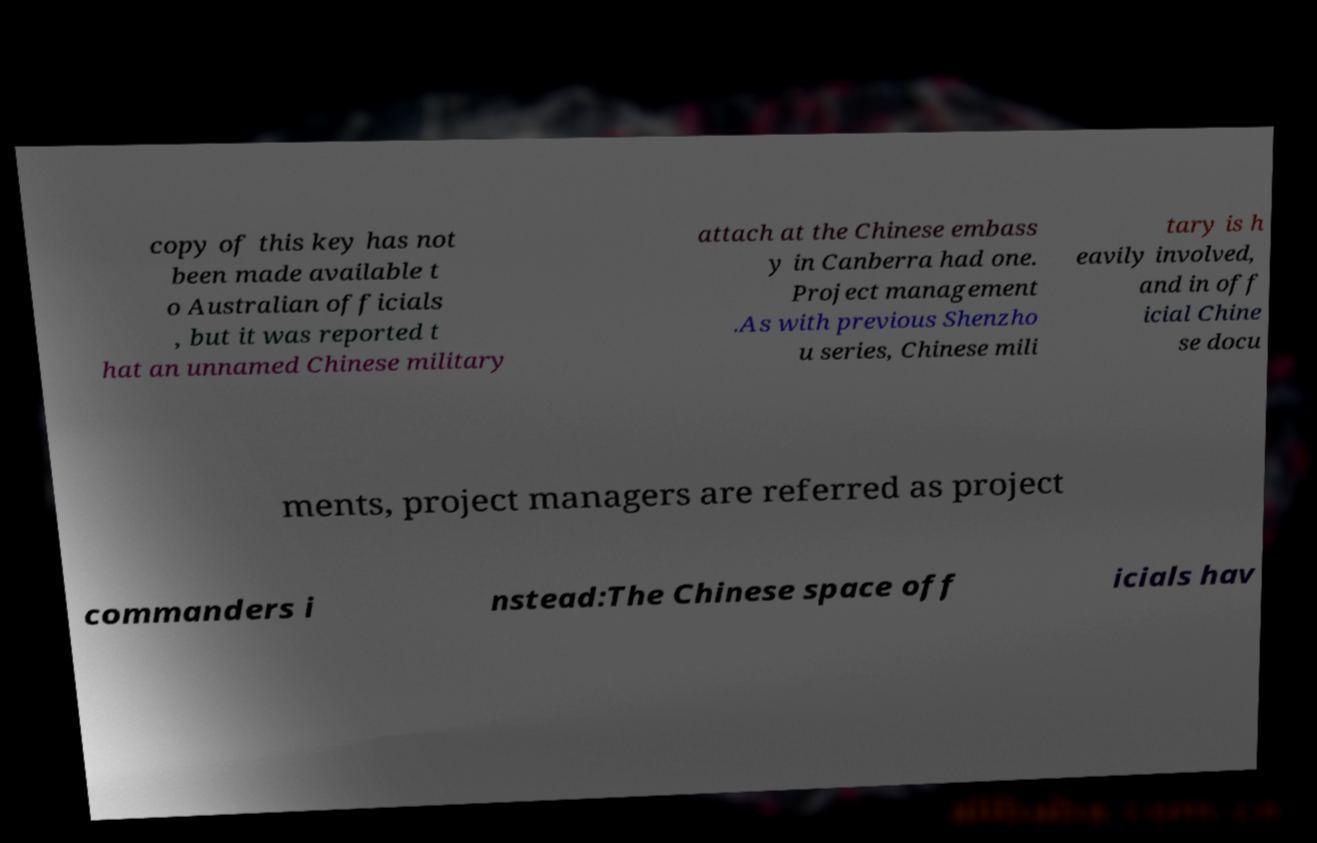Can you accurately transcribe the text from the provided image for me? copy of this key has not been made available t o Australian officials , but it was reported t hat an unnamed Chinese military attach at the Chinese embass y in Canberra had one. Project management .As with previous Shenzho u series, Chinese mili tary is h eavily involved, and in off icial Chine se docu ments, project managers are referred as project commanders i nstead:The Chinese space off icials hav 